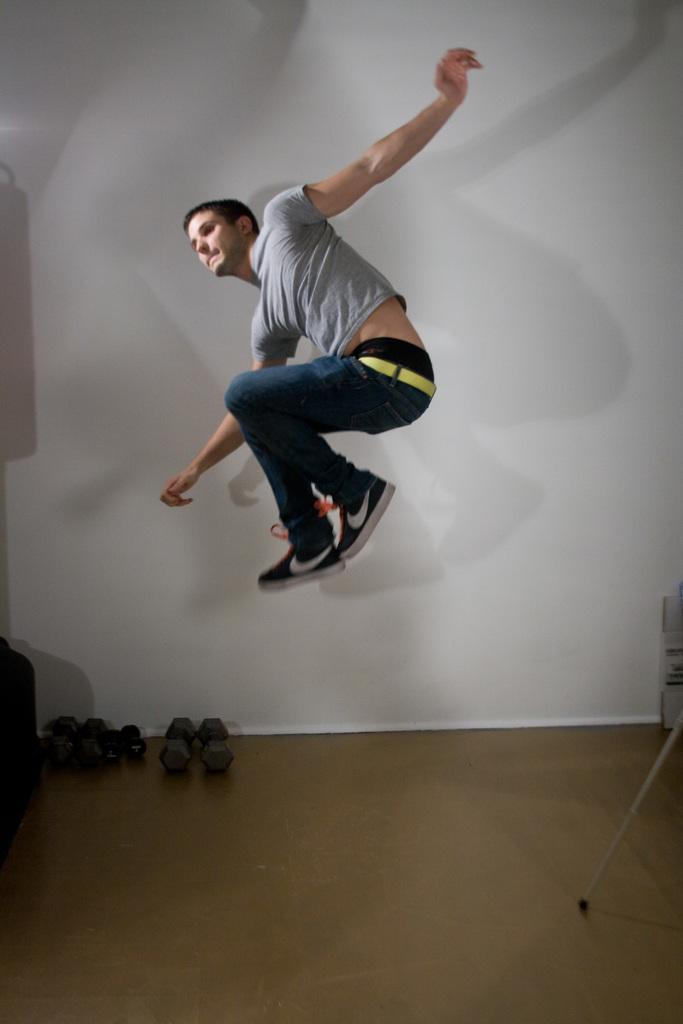In one or two sentences, can you explain what this image depicts? In this image we can see a person wearing ash color T-shirt, blue color jeans jumping in the air and in the background of the image there are some dumbbells and there is a wall. 